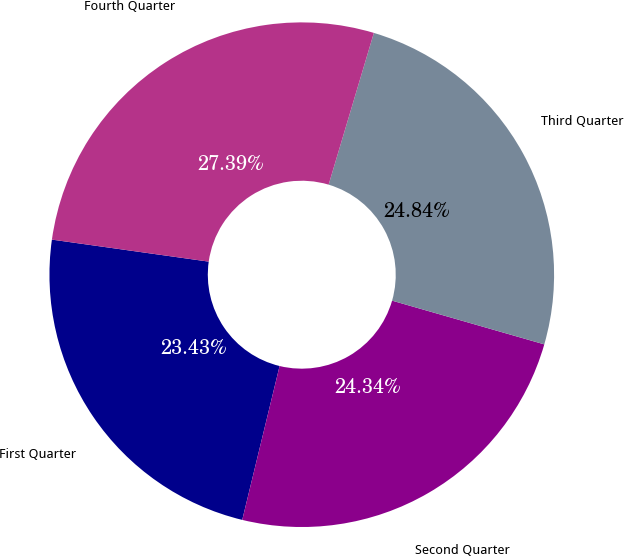Convert chart. <chart><loc_0><loc_0><loc_500><loc_500><pie_chart><fcel>First Quarter<fcel>Second Quarter<fcel>Third Quarter<fcel>Fourth Quarter<nl><fcel>23.43%<fcel>24.34%<fcel>24.84%<fcel>27.39%<nl></chart> 